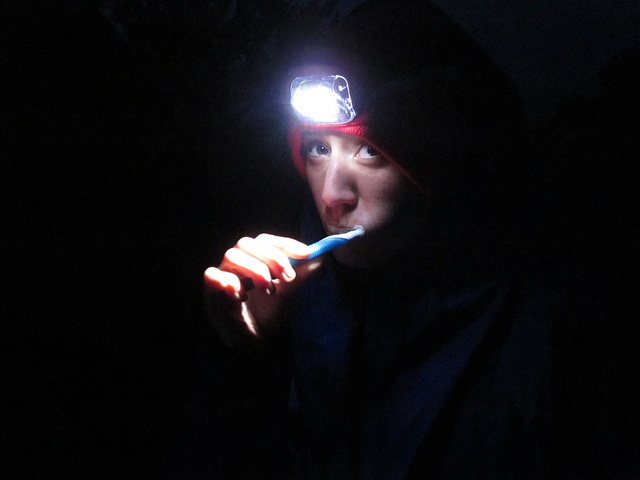Describe the objects in this image and their specific colors. I can see people in black, white, maroon, and purple tones and toothbrush in black, white, navy, and lightblue tones in this image. 